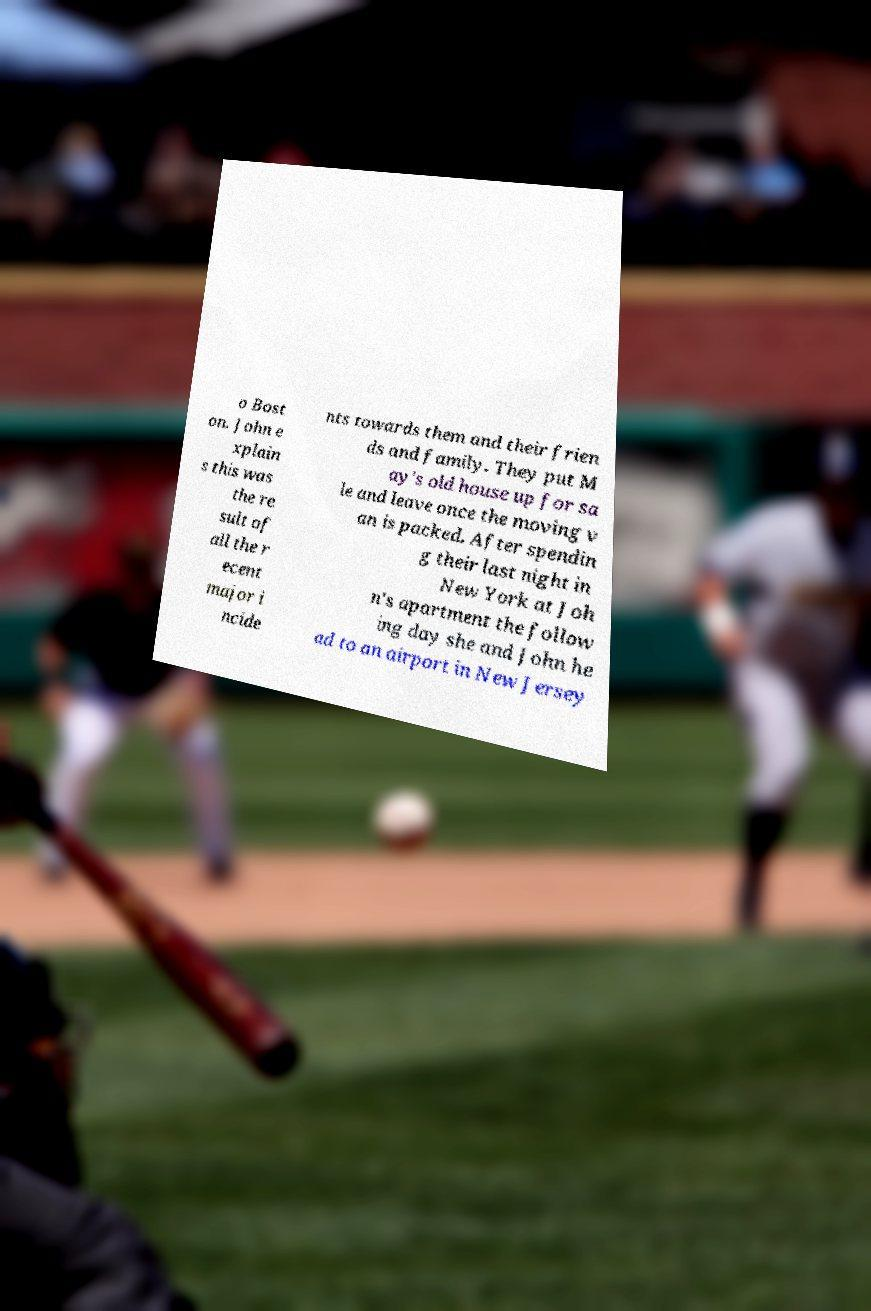I need the written content from this picture converted into text. Can you do that? o Bost on. John e xplain s this was the re sult of all the r ecent major i ncide nts towards them and their frien ds and family. They put M ay's old house up for sa le and leave once the moving v an is packed. After spendin g their last night in New York at Joh n's apartment the follow ing day she and John he ad to an airport in New Jersey 